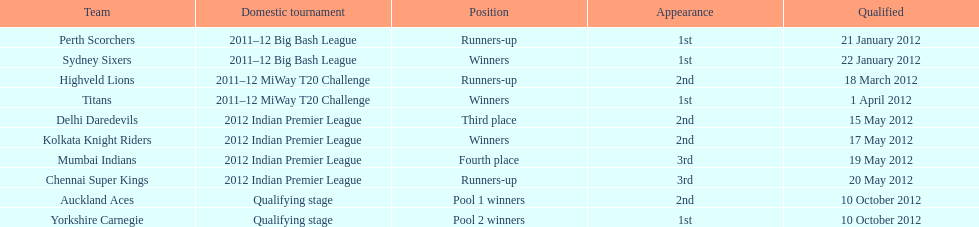On which date did the auckland aces and yorkshire carnegie qualify? 10 October 2012. 